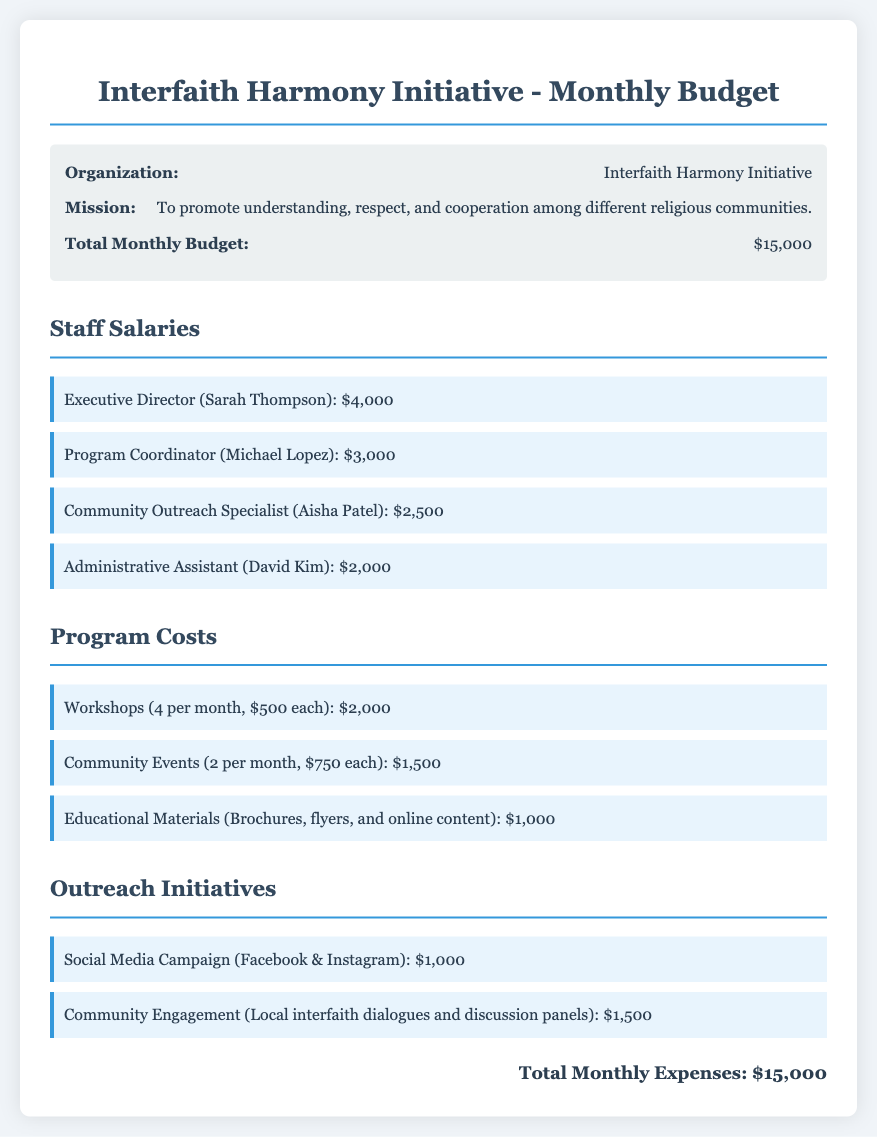What is the total monthly budget? The total monthly budget is stated in the document as $15,000.
Answer: $15,000 Who is the Executive Director? The document lists the name and role of the Executive Director as Sarah Thompson.
Answer: Sarah Thompson How many workshops are held per month? The document specifies that there are 4 workshops held per month.
Answer: 4 What is the cost of the community engagement initiative? The cost for community engagement is detailed as $1,500 in the outreach initiatives section.
Answer: $1,500 What is the total amount allocated for staff salaries? To determine the total staff salaries, you would add the individual salaries listed in the document: $4,000 + $3,000 + $2,500 + $2,000, which equals $11,500.
Answer: $11,500 What kind of materials are included in the educational costs? The document identifies "Brochures, flyers, and online content" as the educational materials included in the program costs.
Answer: Brochures, flyers, and online content How much is allocated for the social media campaign? The document states the allocation for the social media campaign is $1,000.
Answer: $1,000 What is the role of Aisha Patel? According to the document, Aisha Patel serves as the Community Outreach Specialist.
Answer: Community Outreach Specialist What does the mission of the organization focus on? The mission focuses on "understanding, respect, and cooperation among different religious communities."
Answer: Understanding, respect, and cooperation among different religious communities 